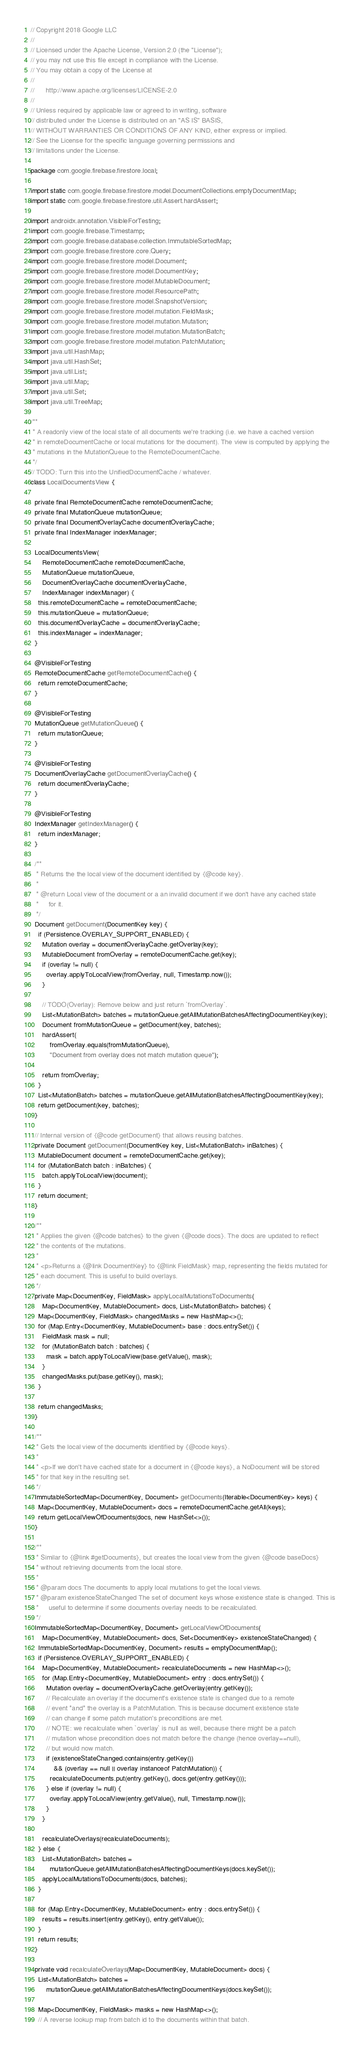Convert code to text. <code><loc_0><loc_0><loc_500><loc_500><_Java_>// Copyright 2018 Google LLC
//
// Licensed under the Apache License, Version 2.0 (the "License");
// you may not use this file except in compliance with the License.
// You may obtain a copy of the License at
//
//      http://www.apache.org/licenses/LICENSE-2.0
//
// Unless required by applicable law or agreed to in writing, software
// distributed under the License is distributed on an "AS IS" BASIS,
// WITHOUT WARRANTIES OR CONDITIONS OF ANY KIND, either express or implied.
// See the License for the specific language governing permissions and
// limitations under the License.

package com.google.firebase.firestore.local;

import static com.google.firebase.firestore.model.DocumentCollections.emptyDocumentMap;
import static com.google.firebase.firestore.util.Assert.hardAssert;

import androidx.annotation.VisibleForTesting;
import com.google.firebase.Timestamp;
import com.google.firebase.database.collection.ImmutableSortedMap;
import com.google.firebase.firestore.core.Query;
import com.google.firebase.firestore.model.Document;
import com.google.firebase.firestore.model.DocumentKey;
import com.google.firebase.firestore.model.MutableDocument;
import com.google.firebase.firestore.model.ResourcePath;
import com.google.firebase.firestore.model.SnapshotVersion;
import com.google.firebase.firestore.model.mutation.FieldMask;
import com.google.firebase.firestore.model.mutation.Mutation;
import com.google.firebase.firestore.model.mutation.MutationBatch;
import com.google.firebase.firestore.model.mutation.PatchMutation;
import java.util.HashMap;
import java.util.HashSet;
import java.util.List;
import java.util.Map;
import java.util.Set;
import java.util.TreeMap;

/**
 * A readonly view of the local state of all documents we're tracking (i.e. we have a cached version
 * in remoteDocumentCache or local mutations for the document). The view is computed by applying the
 * mutations in the MutationQueue to the RemoteDocumentCache.
 */
// TODO: Turn this into the UnifiedDocumentCache / whatever.
class LocalDocumentsView {

  private final RemoteDocumentCache remoteDocumentCache;
  private final MutationQueue mutationQueue;
  private final DocumentOverlayCache documentOverlayCache;
  private final IndexManager indexManager;

  LocalDocumentsView(
      RemoteDocumentCache remoteDocumentCache,
      MutationQueue mutationQueue,
      DocumentOverlayCache documentOverlayCache,
      IndexManager indexManager) {
    this.remoteDocumentCache = remoteDocumentCache;
    this.mutationQueue = mutationQueue;
    this.documentOverlayCache = documentOverlayCache;
    this.indexManager = indexManager;
  }

  @VisibleForTesting
  RemoteDocumentCache getRemoteDocumentCache() {
    return remoteDocumentCache;
  }

  @VisibleForTesting
  MutationQueue getMutationQueue() {
    return mutationQueue;
  }

  @VisibleForTesting
  DocumentOverlayCache getDocumentOverlayCache() {
    return documentOverlayCache;
  }

  @VisibleForTesting
  IndexManager getIndexManager() {
    return indexManager;
  }

  /**
   * Returns the the local view of the document identified by {@code key}.
   *
   * @return Local view of the document or a an invalid document if we don't have any cached state
   *     for it.
   */
  Document getDocument(DocumentKey key) {
    if (Persistence.OVERLAY_SUPPORT_ENABLED) {
      Mutation overlay = documentOverlayCache.getOverlay(key);
      MutableDocument fromOverlay = remoteDocumentCache.get(key);
      if (overlay != null) {
        overlay.applyToLocalView(fromOverlay, null, Timestamp.now());
      }

      // TODO(Overlay): Remove below and just return `fromOverlay`.
      List<MutationBatch> batches = mutationQueue.getAllMutationBatchesAffectingDocumentKey(key);
      Document fromMutationQueue = getDocument(key, batches);
      hardAssert(
          fromOverlay.equals(fromMutationQueue),
          "Document from overlay does not match mutation queue");

      return fromOverlay;
    }
    List<MutationBatch> batches = mutationQueue.getAllMutationBatchesAffectingDocumentKey(key);
    return getDocument(key, batches);
  }

  // Internal version of {@code getDocument} that allows reusing batches.
  private Document getDocument(DocumentKey key, List<MutationBatch> inBatches) {
    MutableDocument document = remoteDocumentCache.get(key);
    for (MutationBatch batch : inBatches) {
      batch.applyToLocalView(document);
    }
    return document;
  }

  /**
   * Applies the given {@code batches} to the given {@code docs}. The docs are updated to reflect
   * the contents of the mutations.
   *
   * <p>Returns a {@link DocumentKey} to {@link FieldMask} map, representing the fields mutated for
   * each document. This is useful to build overlays.
   */
  private Map<DocumentKey, FieldMask> applyLocalMutationsToDocuments(
      Map<DocumentKey, MutableDocument> docs, List<MutationBatch> batches) {
    Map<DocumentKey, FieldMask> changedMasks = new HashMap<>();
    for (Map.Entry<DocumentKey, MutableDocument> base : docs.entrySet()) {
      FieldMask mask = null;
      for (MutationBatch batch : batches) {
        mask = batch.applyToLocalView(base.getValue(), mask);
      }
      changedMasks.put(base.getKey(), mask);
    }

    return changedMasks;
  }

  /**
   * Gets the local view of the documents identified by {@code keys}.
   *
   * <p>If we don't have cached state for a document in {@code keys}, a NoDocument will be stored
   * for that key in the resulting set.
   */
  ImmutableSortedMap<DocumentKey, Document> getDocuments(Iterable<DocumentKey> keys) {
    Map<DocumentKey, MutableDocument> docs = remoteDocumentCache.getAll(keys);
    return getLocalViewOfDocuments(docs, new HashSet<>());
  }

  /**
   * Similar to {@link #getDocuments}, but creates the local view from the given {@code baseDocs}
   * without retrieving documents from the local store.
   *
   * @param docs The documents to apply local mutations to get the local views.
   * @param existenceStateChanged The set of document keys whose existence state is changed. This is
   *     useful to determine if some documents overlay needs to be recalculated.
   */
  ImmutableSortedMap<DocumentKey, Document> getLocalViewOfDocuments(
      Map<DocumentKey, MutableDocument> docs, Set<DocumentKey> existenceStateChanged) {
    ImmutableSortedMap<DocumentKey, Document> results = emptyDocumentMap();
    if (Persistence.OVERLAY_SUPPORT_ENABLED) {
      Map<DocumentKey, MutableDocument> recalculateDocuments = new HashMap<>();
      for (Map.Entry<DocumentKey, MutableDocument> entry : docs.entrySet()) {
        Mutation overlay = documentOverlayCache.getOverlay(entry.getKey());
        // Recalculate an overlay if the document's existence state is changed due to a remote
        // event *and* the overlay is a PatchMutation. This is because document existence state
        // can change if some patch mutation's preconditions are met.
        // NOTE: we recalculate when `overlay` is null as well, because there might be a patch
        // mutation whose precondition does not match before the change (hence overlay==null),
        // but would now match.
        if (existenceStateChanged.contains(entry.getKey())
            && (overlay == null || overlay instanceof PatchMutation)) {
          recalculateDocuments.put(entry.getKey(), docs.get(entry.getKey()));
        } else if (overlay != null) {
          overlay.applyToLocalView(entry.getValue(), null, Timestamp.now());
        }
      }

      recalculateOverlays(recalculateDocuments);
    } else {
      List<MutationBatch> batches =
          mutationQueue.getAllMutationBatchesAffectingDocumentKeys(docs.keySet());
      applyLocalMutationsToDocuments(docs, batches);
    }

    for (Map.Entry<DocumentKey, MutableDocument> entry : docs.entrySet()) {
      results = results.insert(entry.getKey(), entry.getValue());
    }
    return results;
  }

  private void recalculateOverlays(Map<DocumentKey, MutableDocument> docs) {
    List<MutationBatch> batches =
        mutationQueue.getAllMutationBatchesAffectingDocumentKeys(docs.keySet());

    Map<DocumentKey, FieldMask> masks = new HashMap<>();
    // A reverse lookup map from batch id to the documents within that batch.</code> 